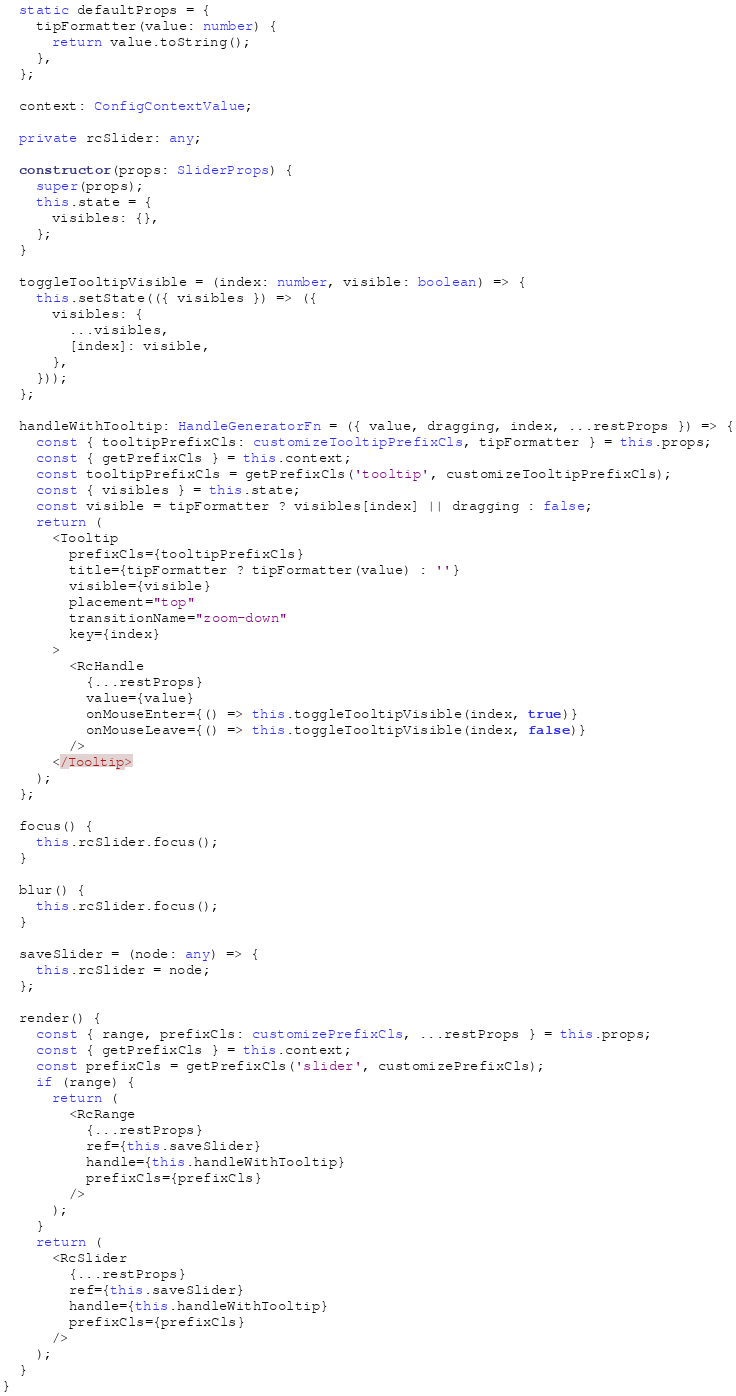Convert code to text. <code><loc_0><loc_0><loc_500><loc_500><_TypeScript_>
  static defaultProps = {
    tipFormatter(value: number) {
      return value.toString();
    },
  };

  context: ConfigContextValue;

  private rcSlider: any;

  constructor(props: SliderProps) {
    super(props);
    this.state = {
      visibles: {},
    };
  }

  toggleTooltipVisible = (index: number, visible: boolean) => {
    this.setState(({ visibles }) => ({
      visibles: {
        ...visibles,
        [index]: visible,
      },
    }));
  };

  handleWithTooltip: HandleGeneratorFn = ({ value, dragging, index, ...restProps }) => {
    const { tooltipPrefixCls: customizeTooltipPrefixCls, tipFormatter } = this.props;
    const { getPrefixCls } = this.context;
    const tooltipPrefixCls = getPrefixCls('tooltip', customizeTooltipPrefixCls);
    const { visibles } = this.state;
    const visible = tipFormatter ? visibles[index] || dragging : false;
    return (
      <Tooltip
        prefixCls={tooltipPrefixCls}
        title={tipFormatter ? tipFormatter(value) : ''}
        visible={visible}
        placement="top"
        transitionName="zoom-down"
        key={index}
      >
        <RcHandle
          {...restProps}
          value={value}
          onMouseEnter={() => this.toggleTooltipVisible(index, true)}
          onMouseLeave={() => this.toggleTooltipVisible(index, false)}
        />
      </Tooltip>
    );
  };

  focus() {
    this.rcSlider.focus();
  }

  blur() {
    this.rcSlider.focus();
  }

  saveSlider = (node: any) => {
    this.rcSlider = node;
  };

  render() {
    const { range, prefixCls: customizePrefixCls, ...restProps } = this.props;
    const { getPrefixCls } = this.context;
    const prefixCls = getPrefixCls('slider', customizePrefixCls);
    if (range) {
      return (
        <RcRange
          {...restProps}
          ref={this.saveSlider}
          handle={this.handleWithTooltip}
          prefixCls={prefixCls}
        />
      );
    }
    return (
      <RcSlider
        {...restProps}
        ref={this.saveSlider}
        handle={this.handleWithTooltip}
        prefixCls={prefixCls}
      />
    );
  }
}
</code> 